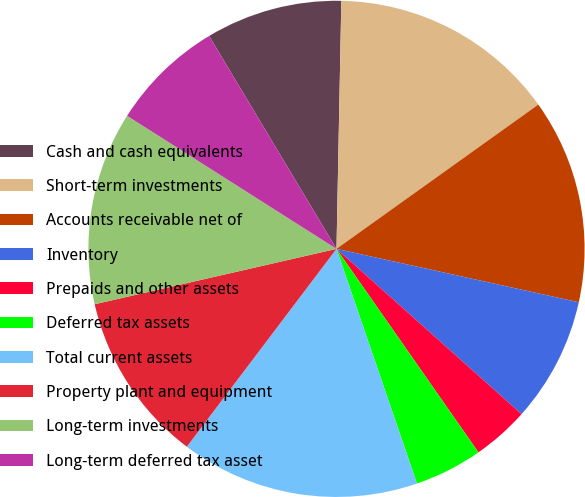Convert chart. <chart><loc_0><loc_0><loc_500><loc_500><pie_chart><fcel>Cash and cash equivalents<fcel>Short-term investments<fcel>Accounts receivable net of<fcel>Inventory<fcel>Prepaids and other assets<fcel>Deferred tax assets<fcel>Total current assets<fcel>Property plant and equipment<fcel>Long-term investments<fcel>Long-term deferred tax asset<nl><fcel>8.89%<fcel>14.81%<fcel>13.33%<fcel>8.15%<fcel>3.7%<fcel>4.44%<fcel>15.56%<fcel>11.11%<fcel>12.59%<fcel>7.41%<nl></chart> 